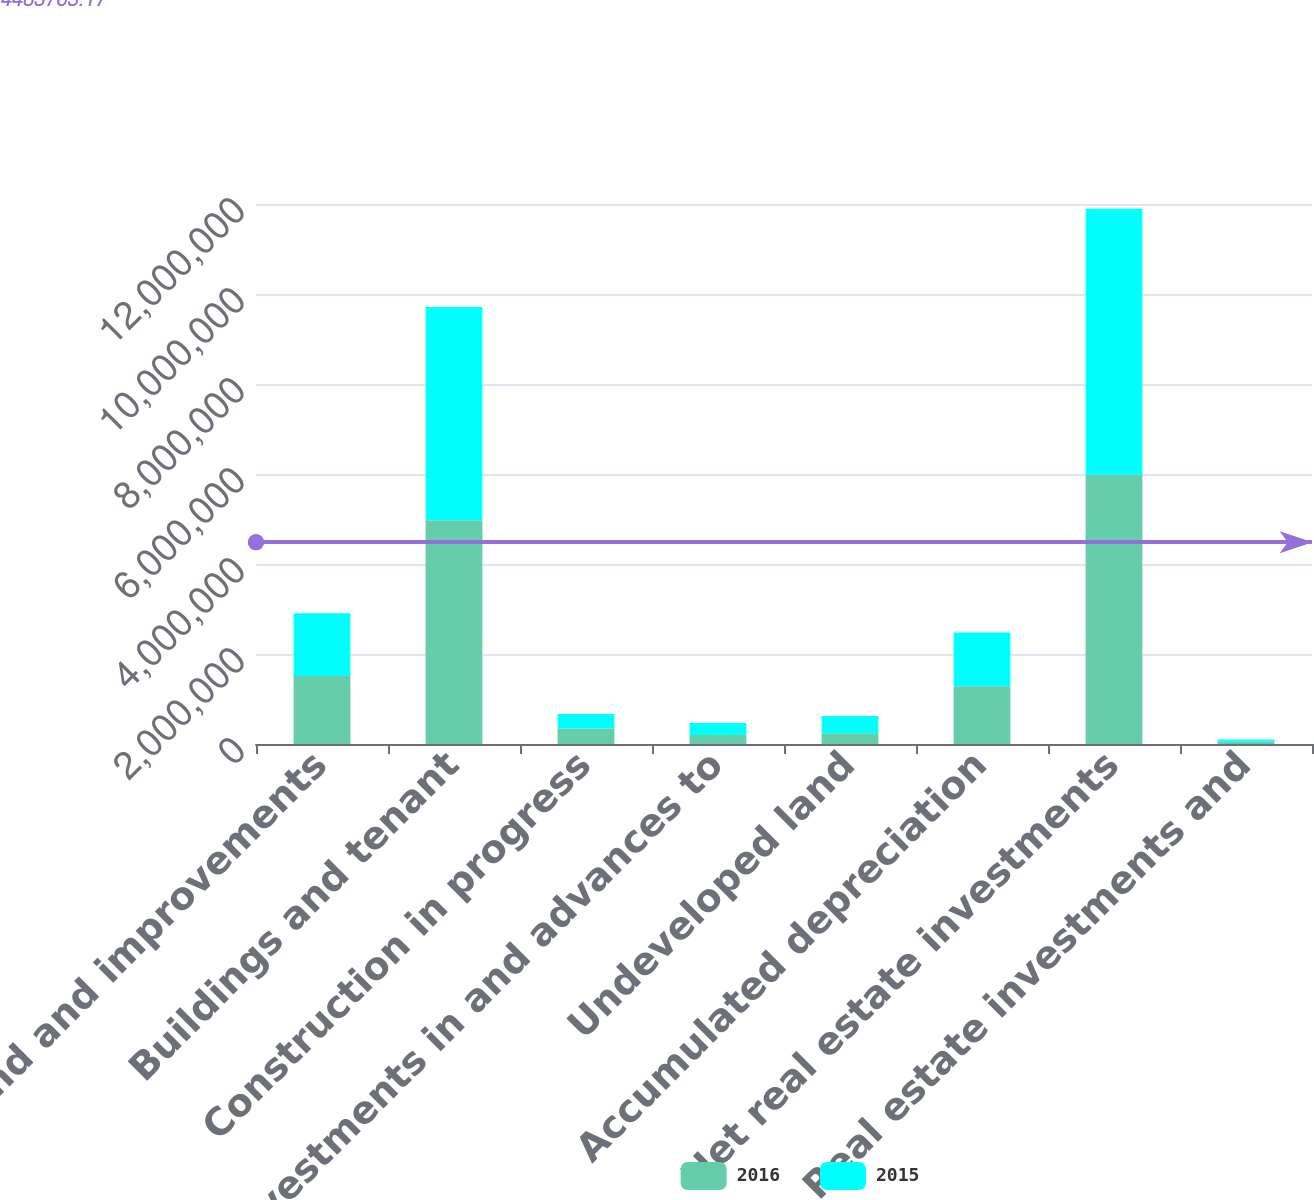<chart> <loc_0><loc_0><loc_500><loc_500><stacked_bar_chart><ecel><fcel>Land and improvements<fcel>Buildings and tenant<fcel>Construction in progress<fcel>Investments in and advances to<fcel>Undeveloped land<fcel>Accumulated depreciation<fcel>Net real estate investments<fcel>Real estate investments and<nl><fcel>2016<fcel>1.51126e+06<fcel>4.97089e+06<fcel>347193<fcel>197807<fcel>237436<fcel>1.28363e+06<fcel>5.98096e+06<fcel>51627<nl><fcel>2015<fcel>1.39176e+06<fcel>4.74084e+06<fcel>321062<fcel>268390<fcel>383045<fcel>1.19242e+06<fcel>5.91267e+06<fcel>45801<nl></chart> 